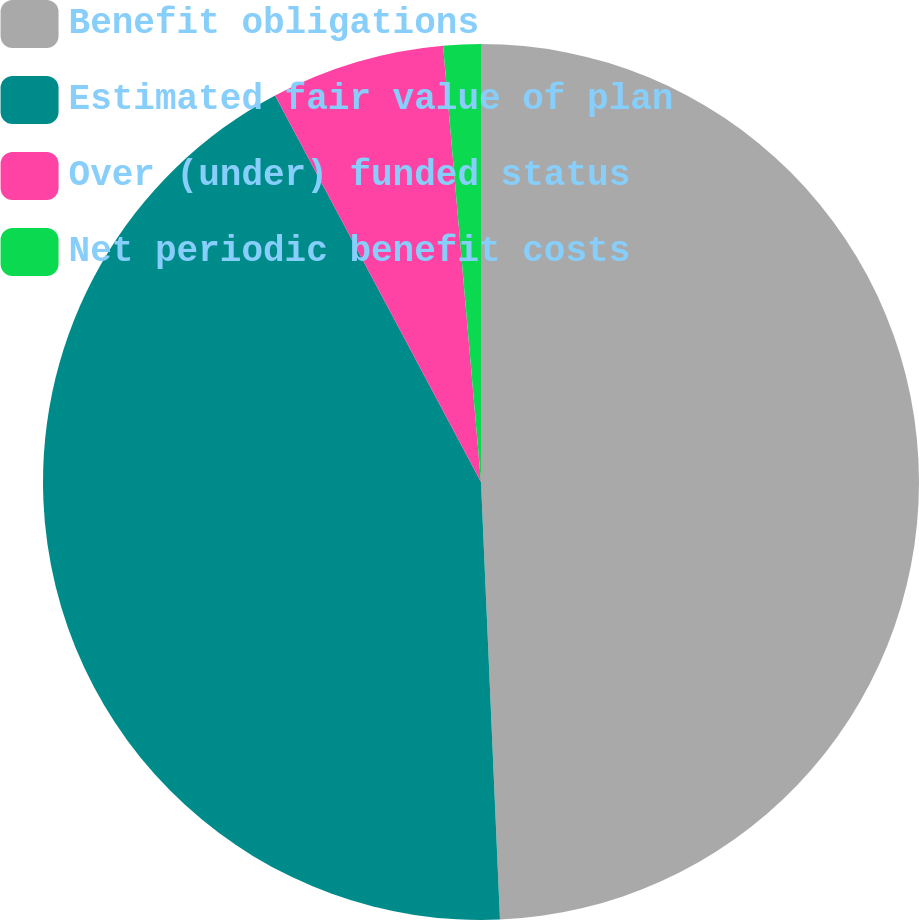Convert chart. <chart><loc_0><loc_0><loc_500><loc_500><pie_chart><fcel>Benefit obligations<fcel>Estimated fair value of plan<fcel>Over (under) funded status<fcel>Net periodic benefit costs<nl><fcel>49.31%<fcel>42.9%<fcel>6.41%<fcel>1.38%<nl></chart> 